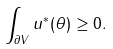<formula> <loc_0><loc_0><loc_500><loc_500>\int _ { \partial V } u ^ { * } ( \theta ) \geq 0 .</formula> 